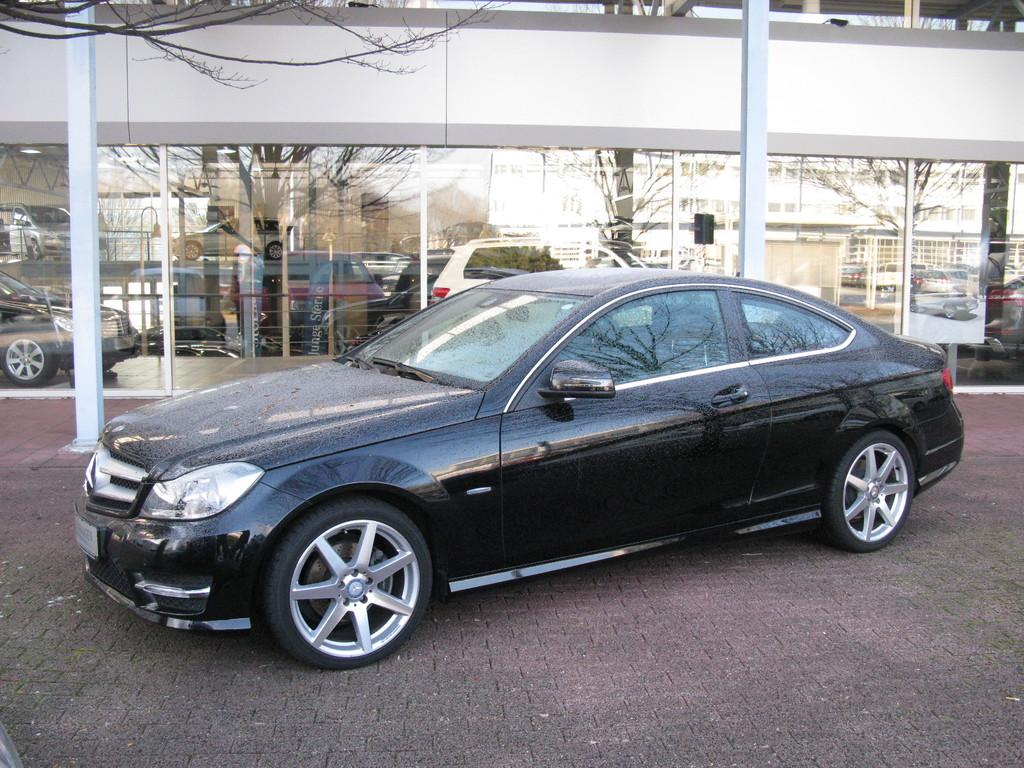What type of vehicles can be seen in the image? There are cars in the image. What type of material is used for the windows in the image? The windows in the image are made of glass. What can be seen reflected on the glass windows? The reflection of trees and buildings is visible on the glass windows. How many sheep are visible in the image? There are no sheep present in the image. Can you describe the person standing near the cars in the image? There is no person visible in the image. 